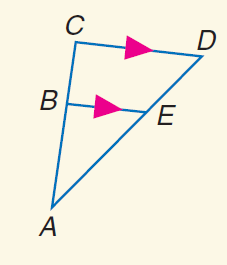Question: Find B C if B E = 24, C D = 32, and A B = 33.
Choices:
A. 11
B. 12
C. 16
D. 44
Answer with the letter. Answer: A Question: Find C D if A E = 8, E D = 4, and B E = 6.
Choices:
A. 4
B. 6
C. 8
D. 9
Answer with the letter. Answer: D Question: Find E D if A B = 6, B C = 4, and A E = 9.
Choices:
A. 3
B. 6
C. 9
D. 13.5
Answer with the letter. Answer: B 